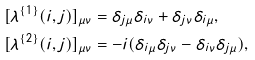Convert formula to latex. <formula><loc_0><loc_0><loc_500><loc_500>[ \lambda ^ { \{ 1 \} } ( i , j ) ] _ { \mu \nu } & = \delta _ { j \mu } \delta _ { i \nu } + \delta _ { j \nu } \delta _ { i \mu } , \\ [ \lambda ^ { \{ 2 \} } ( i , j ) ] _ { \mu \nu } & = - i ( \delta _ { i \mu } \delta _ { j \nu } - \delta _ { i \nu } \delta _ { j \mu } ) ,</formula> 